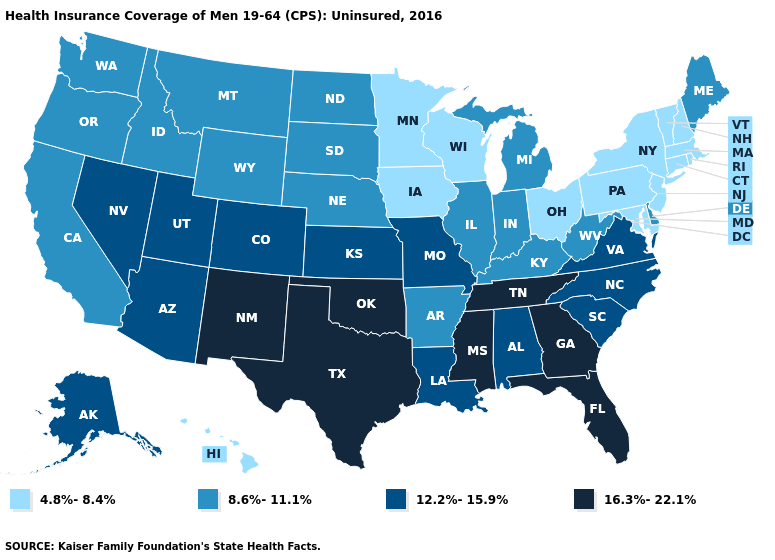What is the value of New York?
Quick response, please. 4.8%-8.4%. Name the states that have a value in the range 4.8%-8.4%?
Quick response, please. Connecticut, Hawaii, Iowa, Maryland, Massachusetts, Minnesota, New Hampshire, New Jersey, New York, Ohio, Pennsylvania, Rhode Island, Vermont, Wisconsin. Does Kansas have the same value as North Carolina?
Short answer required. Yes. Which states have the lowest value in the USA?
Short answer required. Connecticut, Hawaii, Iowa, Maryland, Massachusetts, Minnesota, New Hampshire, New Jersey, New York, Ohio, Pennsylvania, Rhode Island, Vermont, Wisconsin. What is the value of Indiana?
Concise answer only. 8.6%-11.1%. Among the states that border Maine , which have the highest value?
Quick response, please. New Hampshire. Does Utah have the lowest value in the USA?
Give a very brief answer. No. What is the value of South Dakota?
Be succinct. 8.6%-11.1%. Which states have the lowest value in the USA?
Write a very short answer. Connecticut, Hawaii, Iowa, Maryland, Massachusetts, Minnesota, New Hampshire, New Jersey, New York, Ohio, Pennsylvania, Rhode Island, Vermont, Wisconsin. Does Oregon have a lower value than Colorado?
Write a very short answer. Yes. Name the states that have a value in the range 4.8%-8.4%?
Write a very short answer. Connecticut, Hawaii, Iowa, Maryland, Massachusetts, Minnesota, New Hampshire, New Jersey, New York, Ohio, Pennsylvania, Rhode Island, Vermont, Wisconsin. What is the value of Utah?
Keep it brief. 12.2%-15.9%. How many symbols are there in the legend?
Write a very short answer. 4. 